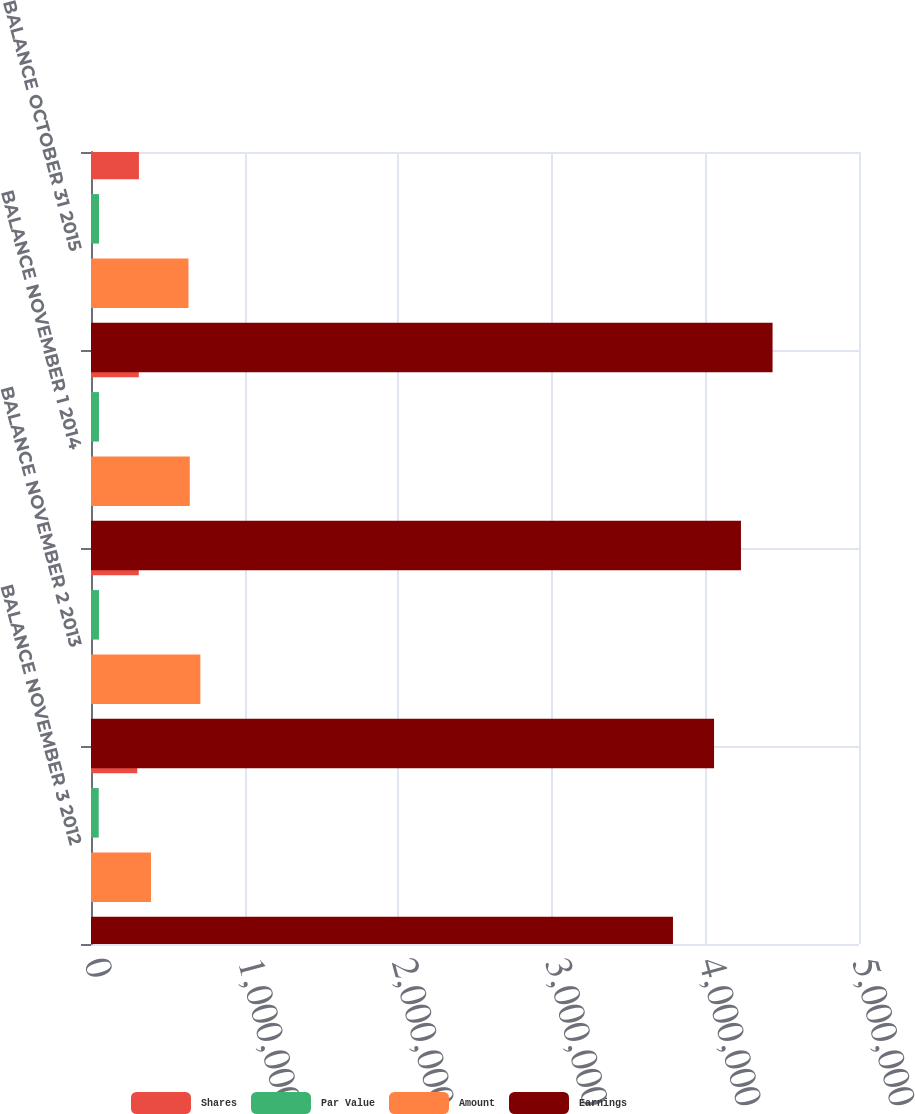<chart> <loc_0><loc_0><loc_500><loc_500><stacked_bar_chart><ecel><fcel>BALANCE NOVEMBER 3 2012<fcel>BALANCE NOVEMBER 2 2013<fcel>BALANCE NOVEMBER 1 2014<fcel>BALANCE OCTOBER 31 2015<nl><fcel>Shares<fcel>301389<fcel>311045<fcel>311205<fcel>312061<nl><fcel>Par Value<fcel>50233<fcel>51842<fcel>51869<fcel>52011<nl><fcel>Amount<fcel>390651<fcel>711879<fcel>643058<fcel>634484<nl><fcel>Earnings<fcel>3.78887e+06<fcel>4.0564e+06<fcel>4.2315e+06<fcel>4.43732e+06<nl></chart> 